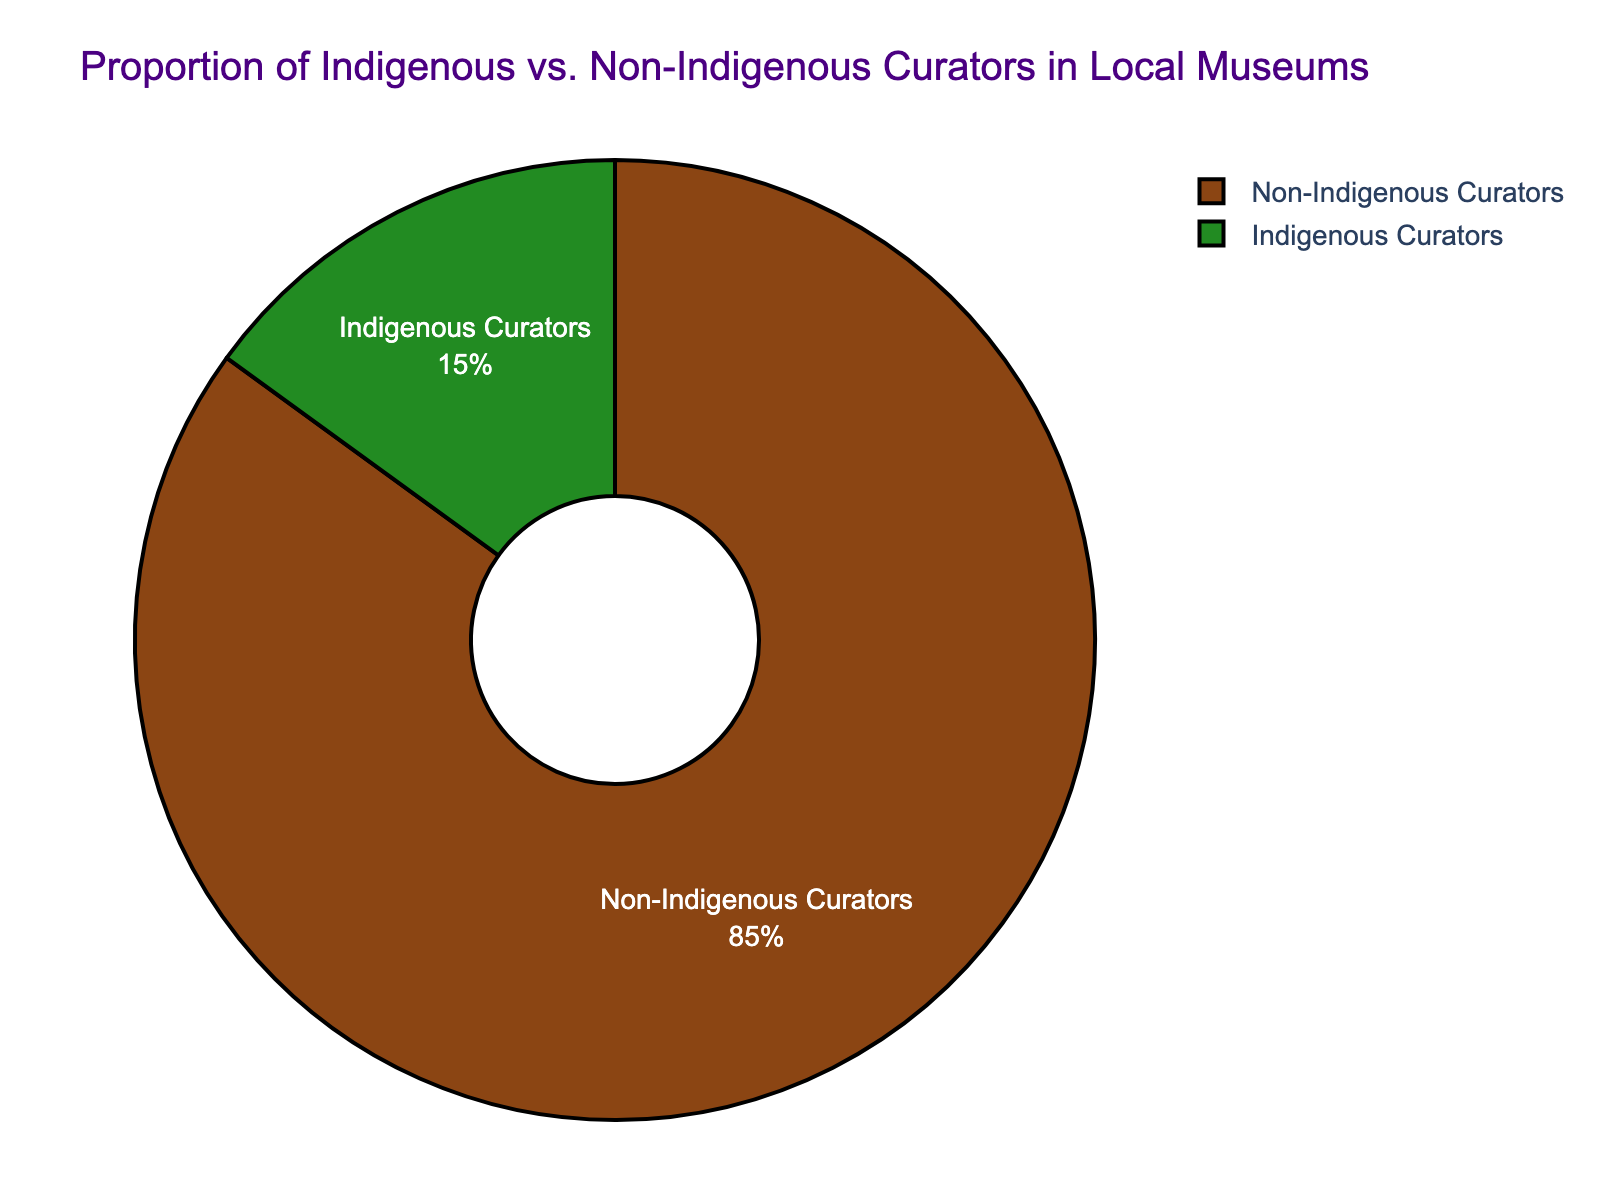What is the proportion of Indigenous Curators in local museums? The chart shows that the segment labeled "Indigenous Curators" represents 15% of the total pie.
Answer: 15% What is the proportion of Non-Indigenous Curators in local museums? The chart illustrates that the segment labeled "Non-Indigenous Curators" makes up 85% of the total pie.
Answer: 85% What is the absolute difference in percentages between Indigenous and Non-Indigenous Curators? The difference is calculated as 85% (Non-Indigenous) - 15% (Indigenous) = 70%.
Answer: 70% What fraction of the total curators are Indigenous Curators? Indigenous Curators make up 15% of the total curator population. Converting this percentage to a fraction results in 15/100, which simplifies to 3/20.
Answer: 3/20 By what factor is the percentage of Non-Indigenous Curators greater than that of Indigenous Curators? To find the factor, divide the percentage of Non-Indigenous Curators by the percentage of Indigenous Curators: 85% / 15% = 5.67.
Answer: 5.67 If there are 100 total curators, how many are Indigenous, and how many are Non-Indigenous? If we follow the percentages, 15% of 100 is 15 Indigenous Curators, and 85% of 100 is 85 Non-Indigenous Curators.
Answer: 15 Indigenous, 85 Non-Indigenous What does the color green represent in the chart? The color green is used to represent the segment labeled "Non-Indigenous Curators."
Answer: Non-Indigenous Curators What does the color brown represent in the chart? The color brown symbolizes the segment labeled "Indigenous Curators."
Answer: Indigenous Curators Is there a larger proportion of Indigenous Curators or Non-Indigenous Curators, and by how much? The chart indicates that there is a larger proportion of Non-Indigenous Curators. The visual difference shows that Non-Indigenous Curators make up 85%, whereas Indigenous Curators account for 15%, leading to a difference of 70%.
Answer: Non-Indigenous Curators by 70% If the total number of curators increases to 200, how many Indigenous Curators would you expect? Maintaining the ratio, 15% of 200 curators would be Indigenous. Calculation: 0.15 * 200 = 30 Indigenous Curators.
Answer: 30 Indigenous Curators 